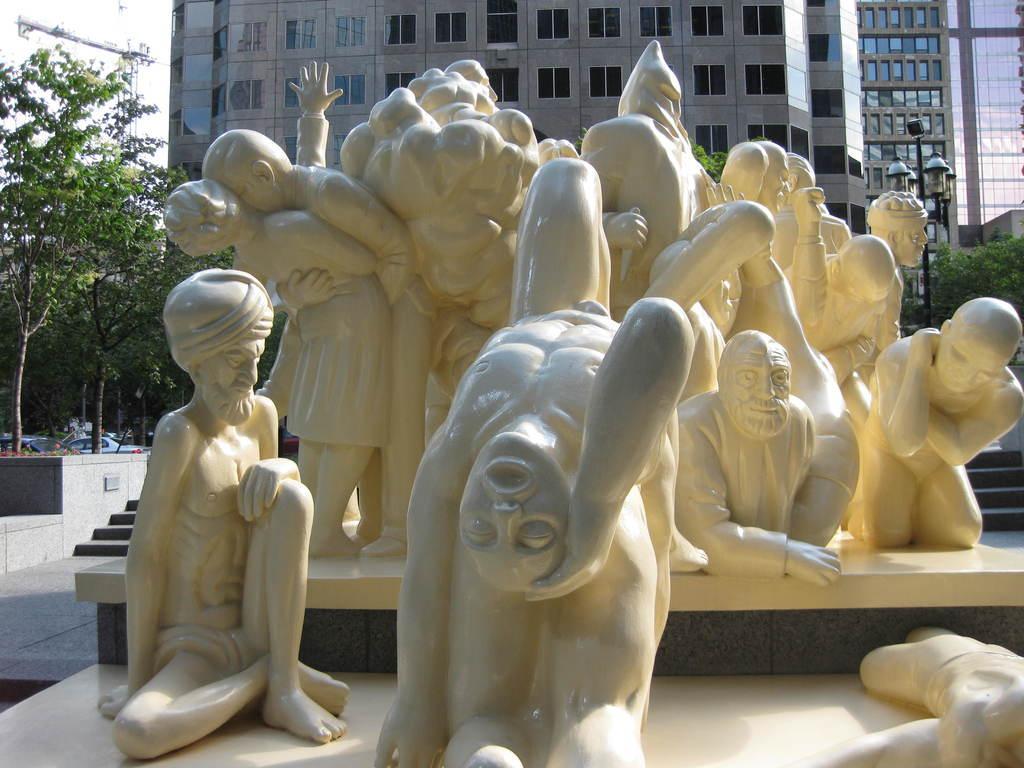Describe this image in one or two sentences. In this picture I can observe statues of humans which are in white color in the middle of the picture. In the background there are trees and a building. 